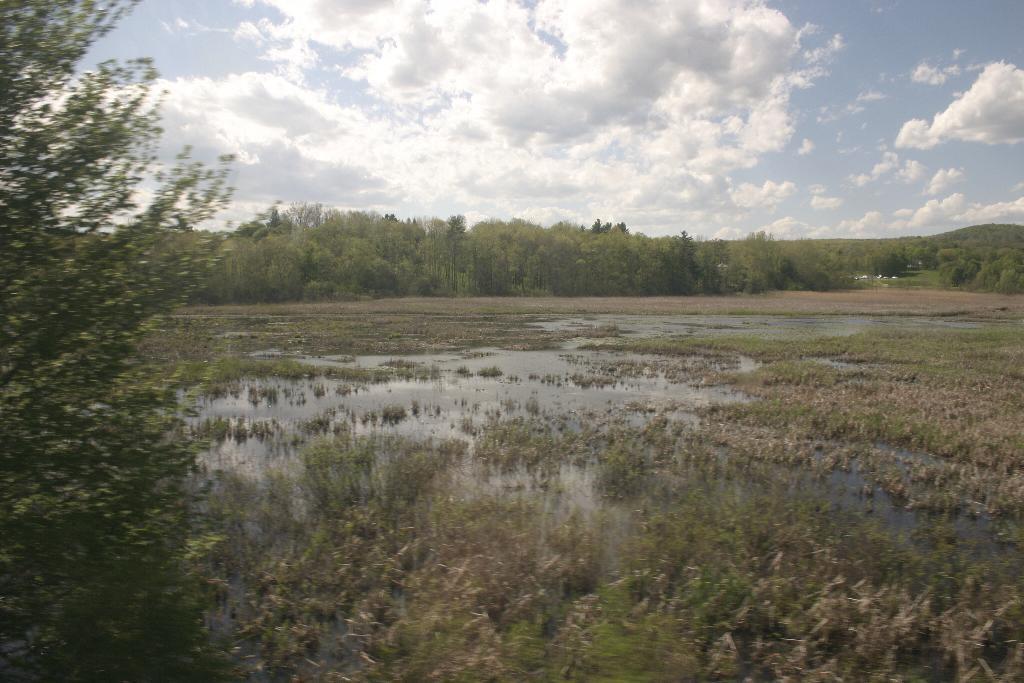Can you describe this image briefly? In this picture we can see water, grass, and trees. In the background there is sky with clouds. 